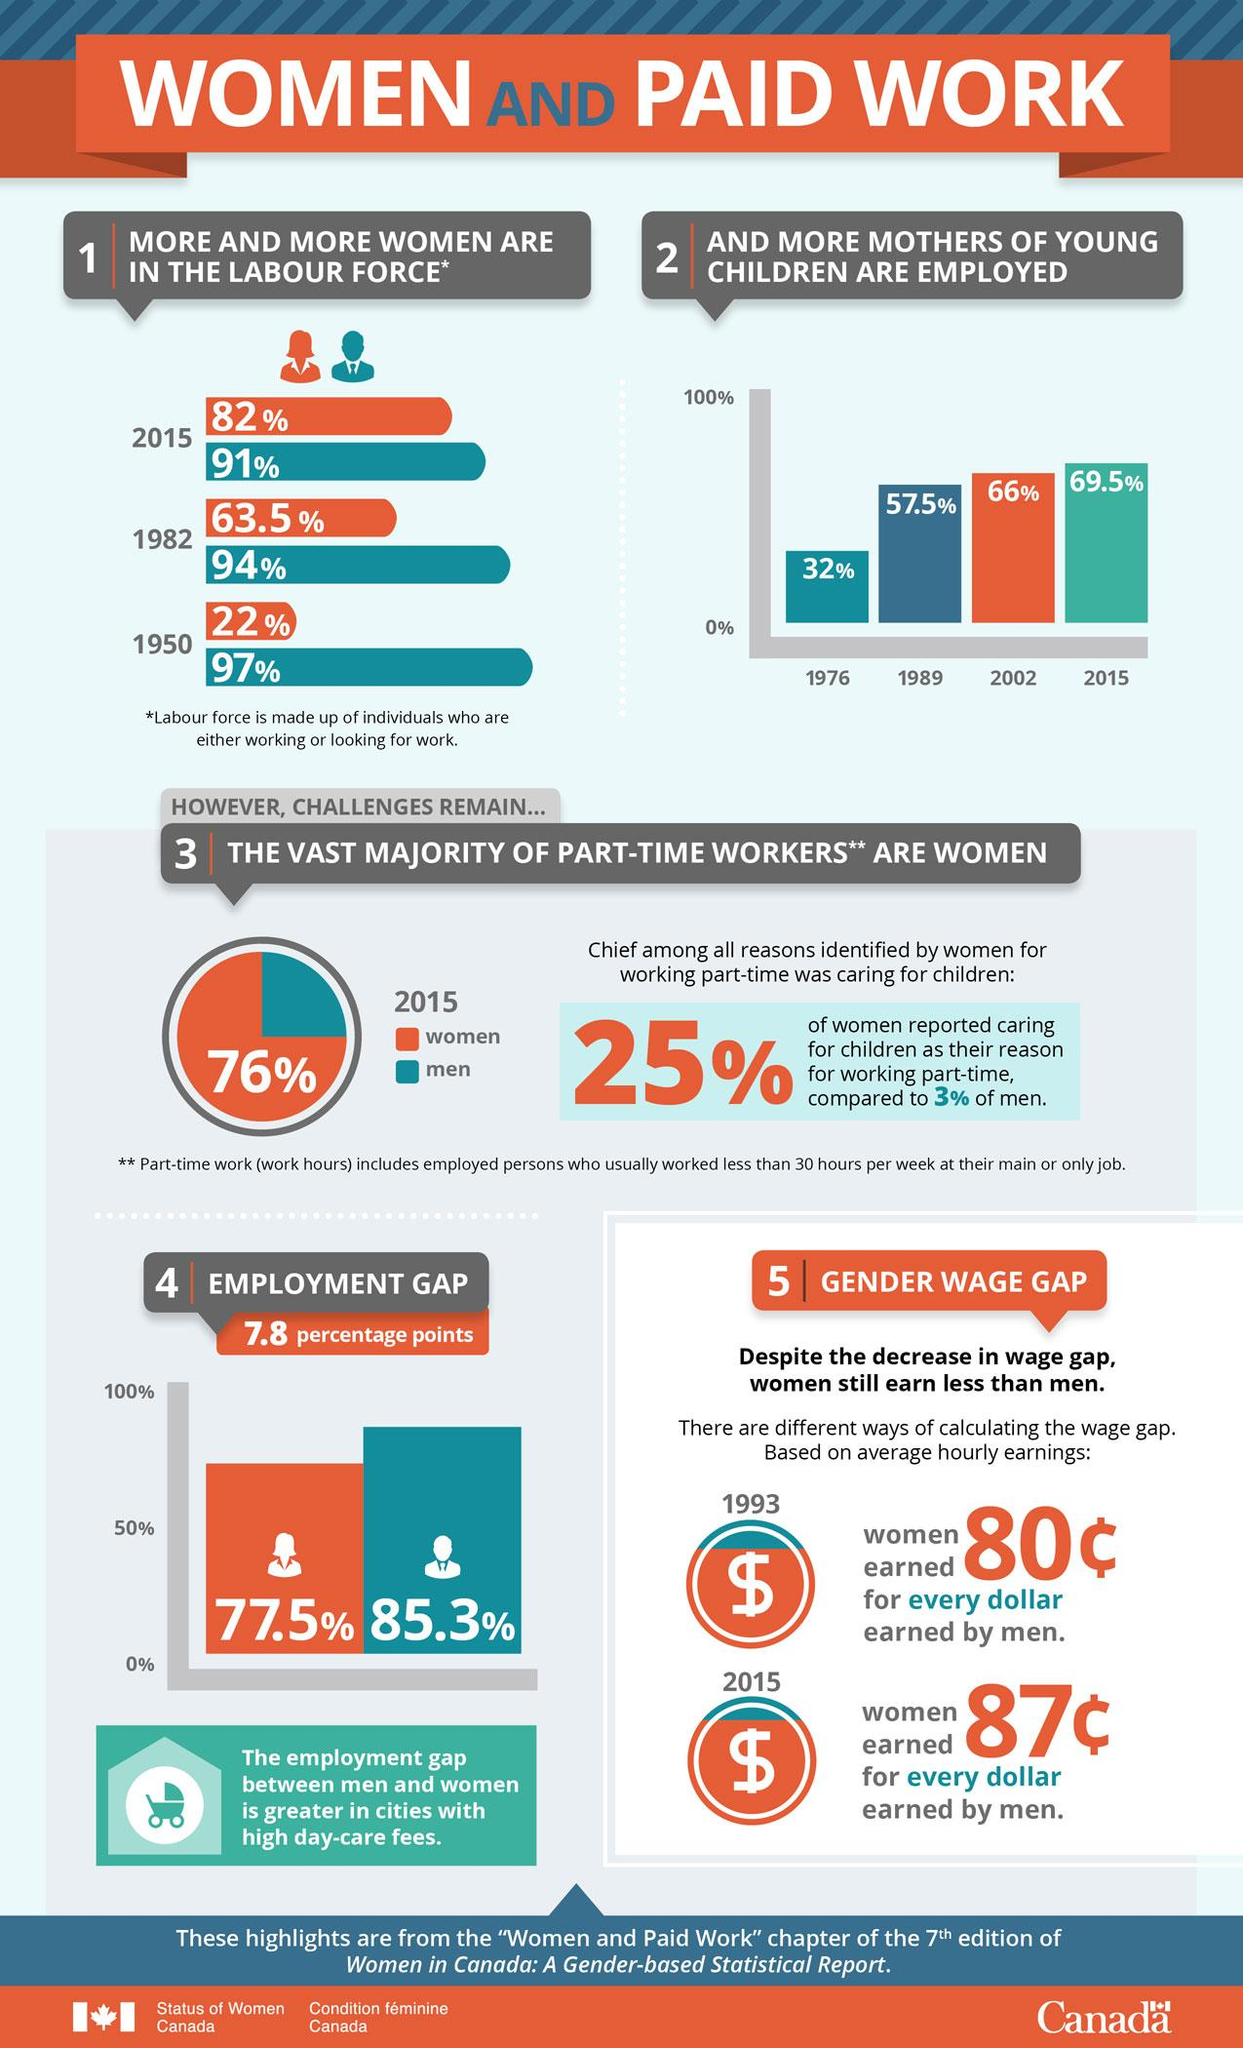Indicate a few pertinent items in this graphic. In 1982, 63.5% of women were a part of the labour force in Canada. In 2015, it was found that 24% of part-time workers in Canada were men. The employment gap between men and women in Canada is 77.5%. In 2015, it was reported that 91% of men in Canada were a part of the labour force. In 2015, a majority of part-time workers in Canada were women, representing 76% of the total. 